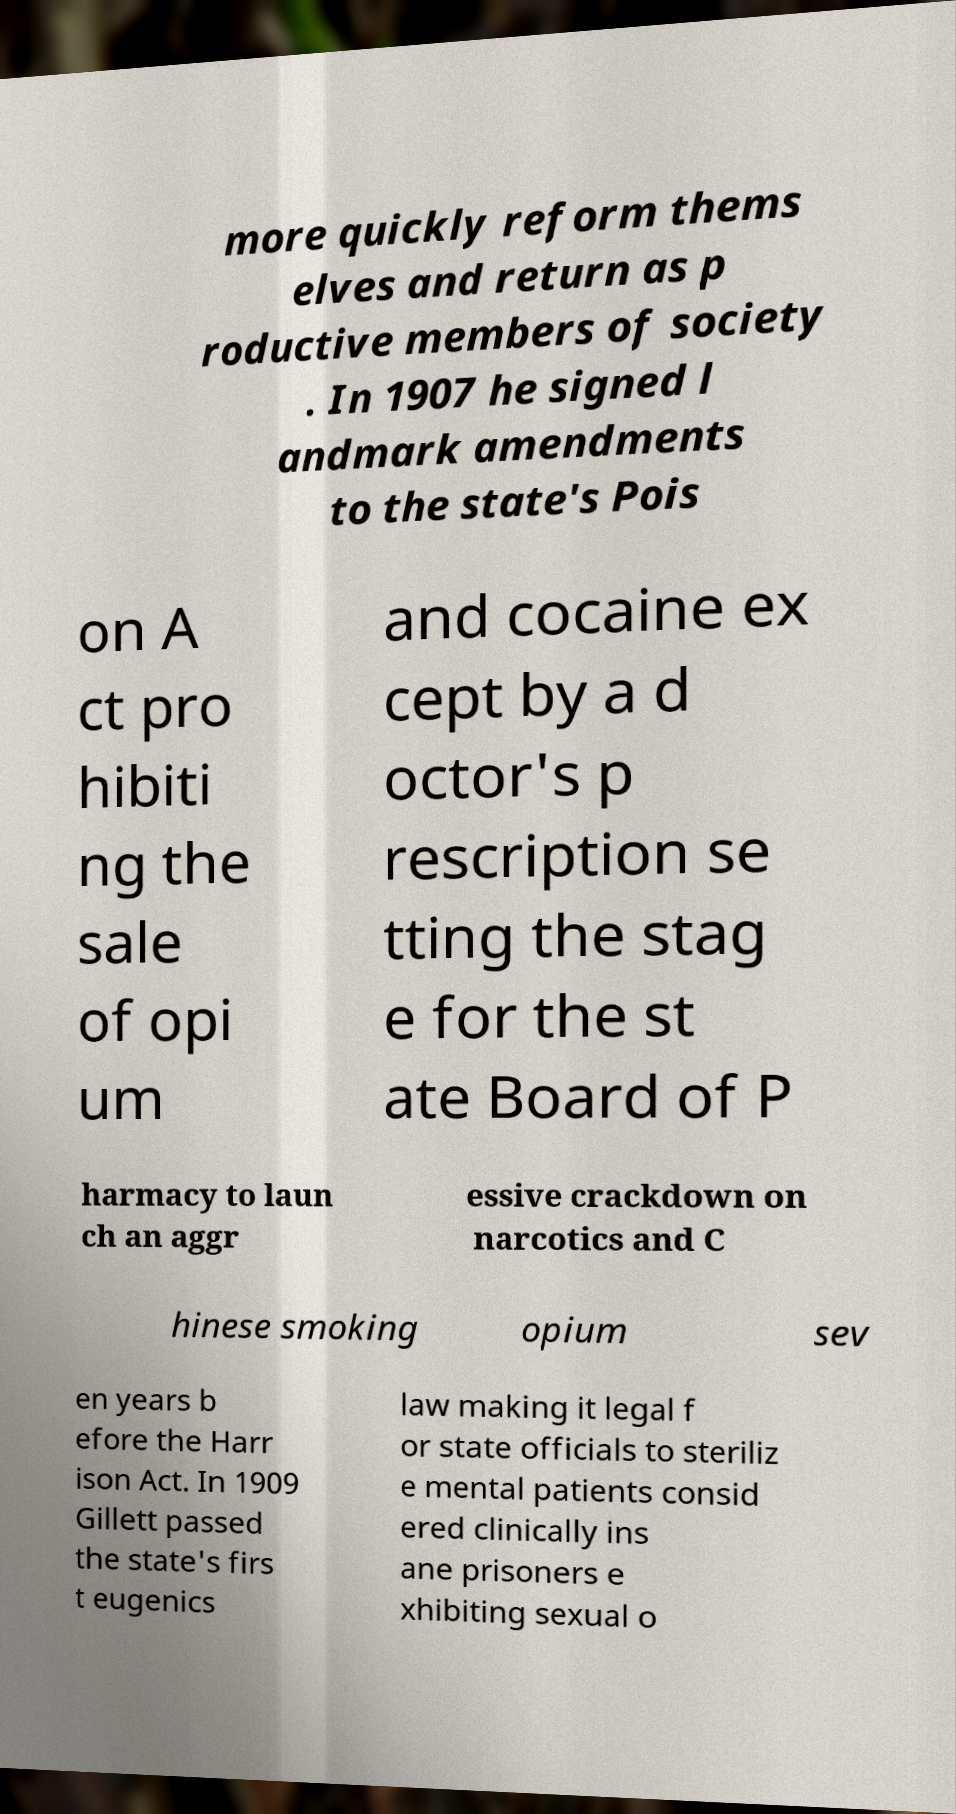Can you read and provide the text displayed in the image?This photo seems to have some interesting text. Can you extract and type it out for me? more quickly reform thems elves and return as p roductive members of society . In 1907 he signed l andmark amendments to the state's Pois on A ct pro hibiti ng the sale of opi um and cocaine ex cept by a d octor's p rescription se tting the stag e for the st ate Board of P harmacy to laun ch an aggr essive crackdown on narcotics and C hinese smoking opium sev en years b efore the Harr ison Act. In 1909 Gillett passed the state's firs t eugenics law making it legal f or state officials to steriliz e mental patients consid ered clinically ins ane prisoners e xhibiting sexual o 